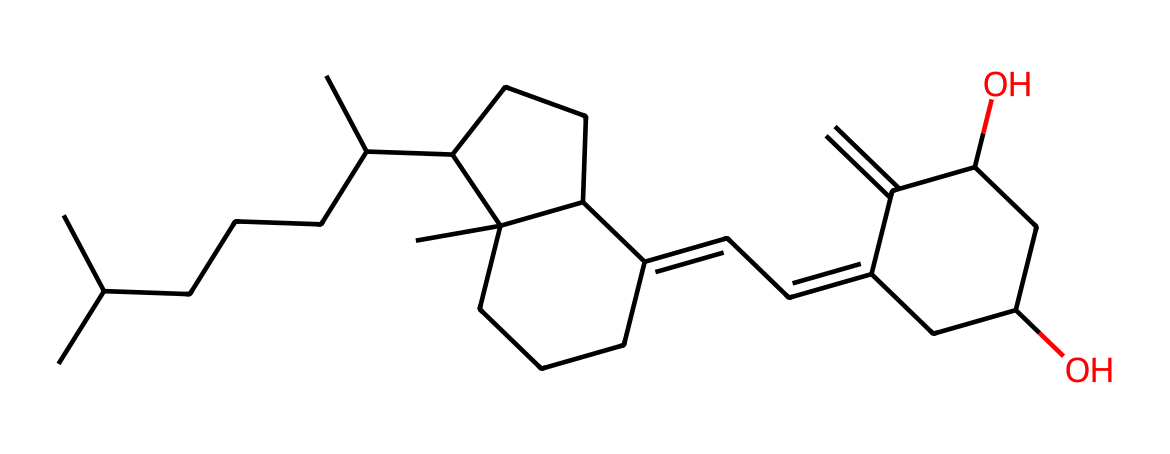how many carbon atoms are present in this chemical? By breaking down the SMILES representation, we can count the letters "C" that represent carbon atoms. In this case, counting the "C" gives a total of 27 carbon atoms.
Answer: 27 what is the common name of this vitamin? This chemical structure corresponds to vitamin D, specifically vitamin D2, which is also known as ergocalciferol.
Answer: vitamin D how many double bonds are there in this structure? Upon analyzing the carbon backbone of the chemical and identifying the double bonds represented by the "=" sign in the SMILES notation, we find that there are 3 double bonds present in this molecule.
Answer: 3 which functional group is primarily represented in this vitamin? The presence of hydroxyl groups (–OH) can be determined in the chemical structure. In this molecule, there are two hydroxyl groups, indicating it's a diol, which is common for vitamin D.
Answer: hydroxyl what is the molecular formula derived from this structure? To derive the molecular formula, we count the number of carbon, hydrogen, and oxygen atoms present. For this structure, the molecular formula determined is C27H44O2.
Answer: C27H44O2 does this vitamin contain any rings in its structure? Analyzing the structure, we can identify several cyclic components, specifically two cyclic structures involving a fused ring system in the overall layout of the SMILES. Thus, it indicates that there are ring structures present.
Answer: yes 